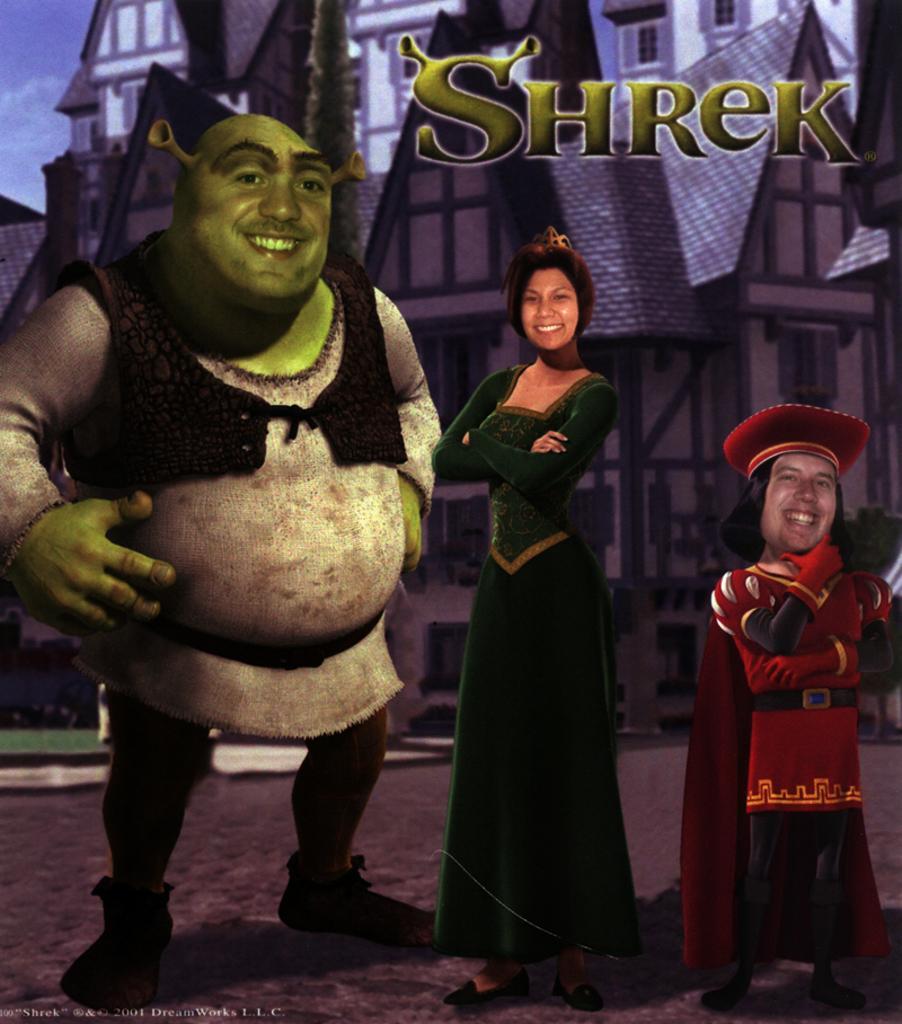Describe this image in one or two sentences. In this animated picture there are two persons and a woman are standing on the road. Behind there is a building. Woman is wearing a green dress. Right side person is wearing a cap and gloves. 